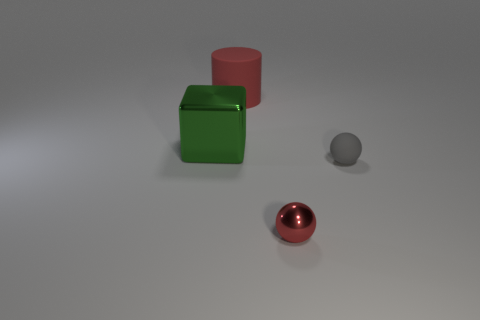Add 1 purple metallic blocks. How many objects exist? 5 Subtract all cylinders. How many objects are left? 3 Add 3 red shiny balls. How many red shiny balls exist? 4 Subtract 0 yellow cylinders. How many objects are left? 4 Subtract all large cylinders. Subtract all brown cylinders. How many objects are left? 3 Add 1 big green metallic blocks. How many big green metallic blocks are left? 2 